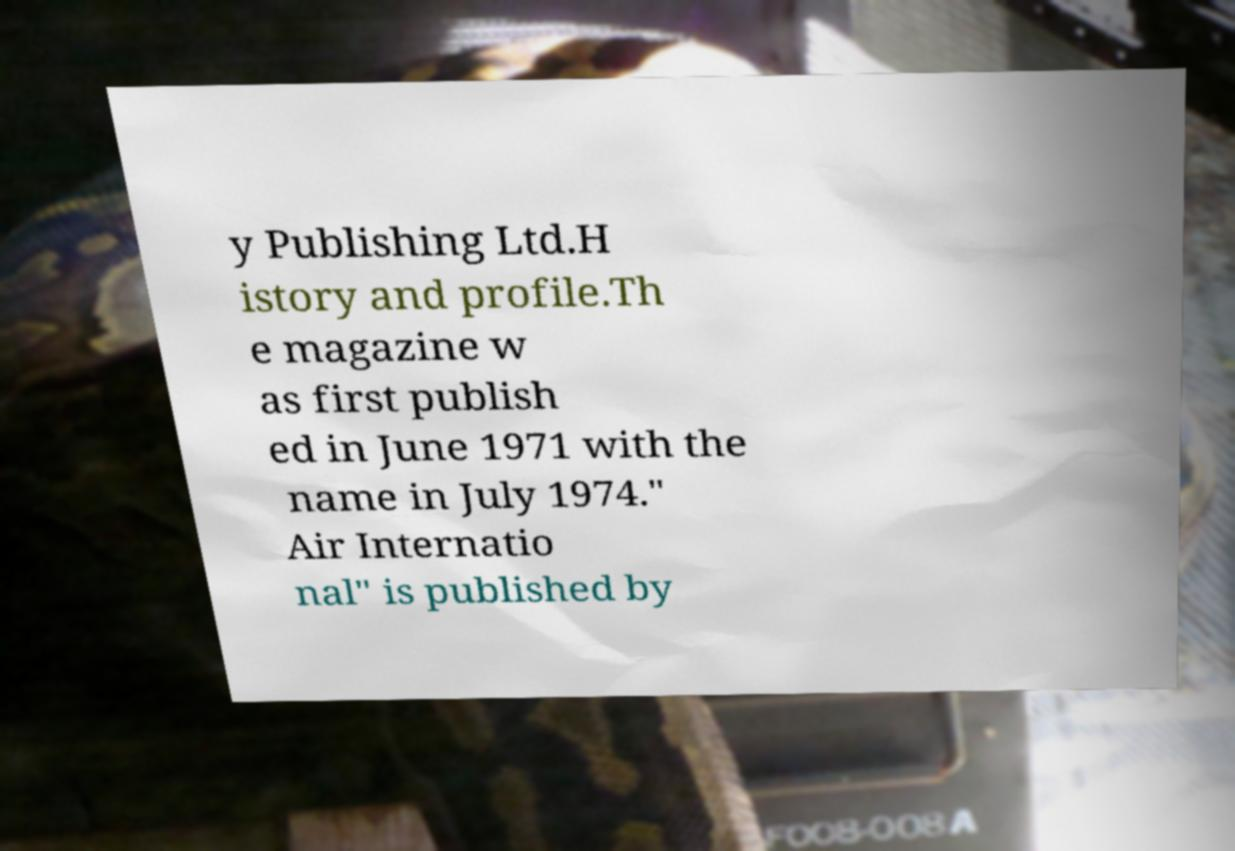Can you accurately transcribe the text from the provided image for me? y Publishing Ltd.H istory and profile.Th e magazine w as first publish ed in June 1971 with the name in July 1974." Air Internatio nal" is published by 